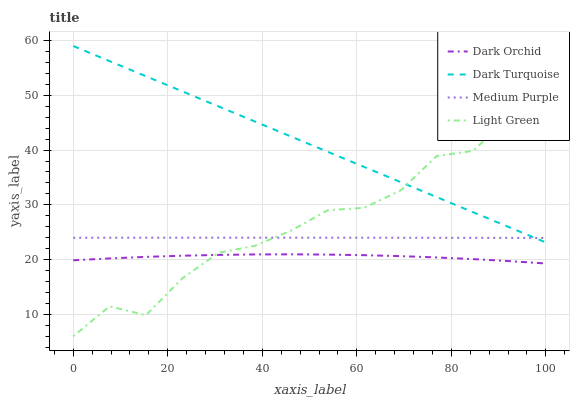Does Dark Orchid have the minimum area under the curve?
Answer yes or no. Yes. Does Dark Turquoise have the maximum area under the curve?
Answer yes or no. Yes. Does Light Green have the minimum area under the curve?
Answer yes or no. No. Does Light Green have the maximum area under the curve?
Answer yes or no. No. Is Dark Turquoise the smoothest?
Answer yes or no. Yes. Is Light Green the roughest?
Answer yes or no. Yes. Is Light Green the smoothest?
Answer yes or no. No. Is Dark Turquoise the roughest?
Answer yes or no. No. Does Dark Turquoise have the lowest value?
Answer yes or no. No. Does Dark Turquoise have the highest value?
Answer yes or no. Yes. Does Light Green have the highest value?
Answer yes or no. No. Is Dark Orchid less than Dark Turquoise?
Answer yes or no. Yes. Is Medium Purple greater than Dark Orchid?
Answer yes or no. Yes. Does Light Green intersect Medium Purple?
Answer yes or no. Yes. Is Light Green less than Medium Purple?
Answer yes or no. No. Is Light Green greater than Medium Purple?
Answer yes or no. No. Does Dark Orchid intersect Dark Turquoise?
Answer yes or no. No. 